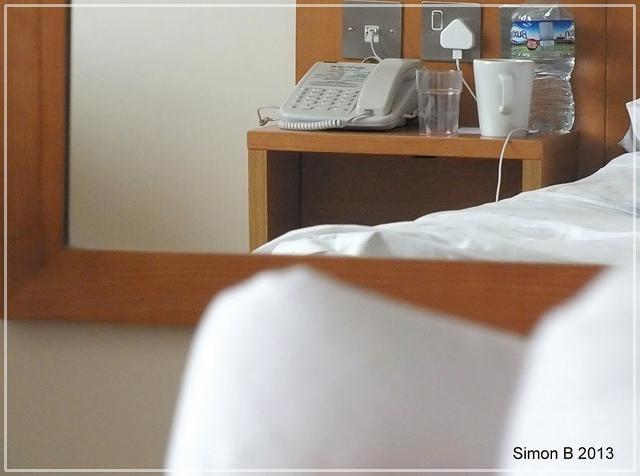What color is the frame of the mirror?
Give a very brief answer. Brown. How many buttons are on the phone?
Concise answer only. 20. Which container could hold coffee?
Give a very brief answer. Coffee cup. 